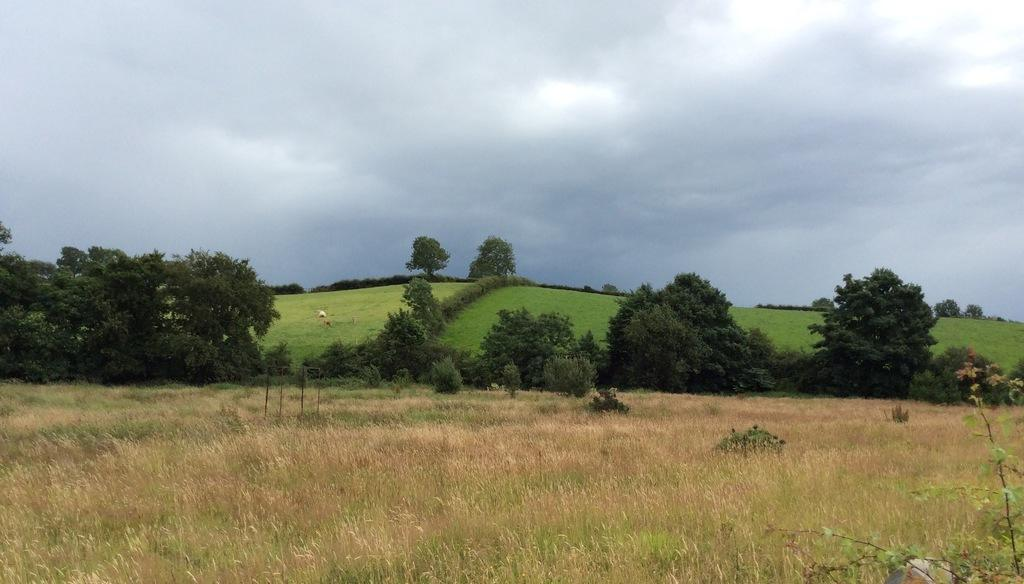What type of vegetation is at the bottom of the image? There is grass at the bottom of the image. What can be seen in the middle of the image? There are groups of trees in the middle of the image. What is visible in the sky in the image? There are clouds in the sky. Can you see any icicles hanging from the trees in the image? There are no icicles present in the image; it features groups of trees and clouds in the sky. Is there an iron object visible in the image? There is no iron object present in the image. 